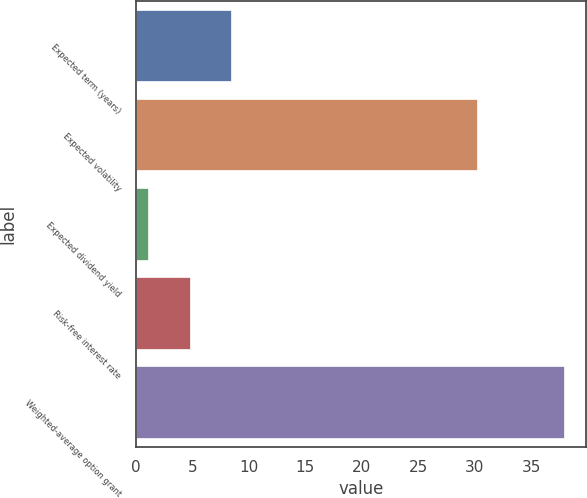Convert chart to OTSL. <chart><loc_0><loc_0><loc_500><loc_500><bar_chart><fcel>Expected term (years)<fcel>Expected volatility<fcel>Expected dividend yield<fcel>Risk-free interest rate<fcel>Weighted-average option grant<nl><fcel>8.46<fcel>30.2<fcel>1.1<fcel>4.78<fcel>37.91<nl></chart> 